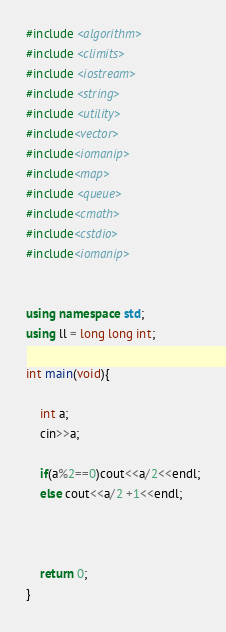<code> <loc_0><loc_0><loc_500><loc_500><_C++_>#include <algorithm>
#include <climits>
#include <iostream>
#include <string>
#include <utility>
#include<vector>
#include<iomanip>
#include<map>
#include <queue>
#include<cmath>
#include<cstdio>
#include<iomanip>


using namespace std;
using ll = long long int; 

int main(void){

    int a;
    cin>>a;

    if(a%2==0)cout<<a/2<<endl;
    else cout<<a/2 +1<<endl;



    return 0;
}</code> 